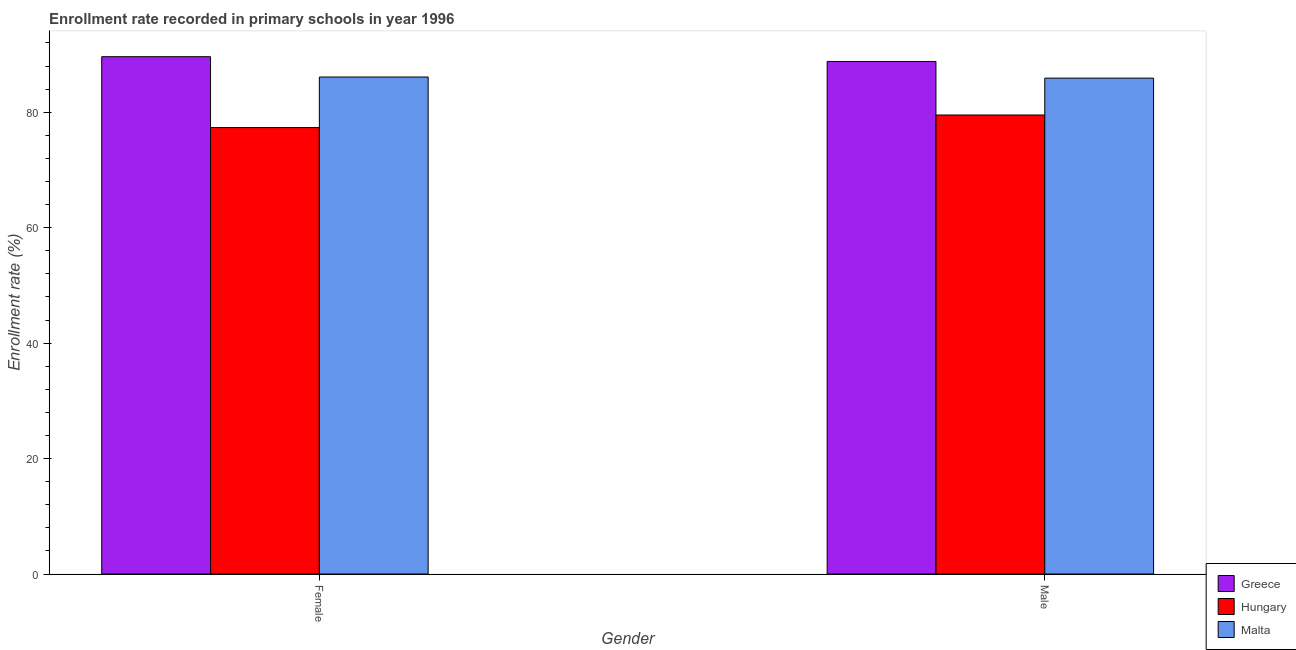Are the number of bars per tick equal to the number of legend labels?
Offer a very short reply. Yes. Are the number of bars on each tick of the X-axis equal?
Offer a very short reply. Yes. How many bars are there on the 1st tick from the right?
Provide a succinct answer. 3. What is the label of the 1st group of bars from the left?
Provide a succinct answer. Female. What is the enrollment rate of female students in Malta?
Ensure brevity in your answer.  86.1. Across all countries, what is the maximum enrollment rate of male students?
Offer a terse response. 88.8. Across all countries, what is the minimum enrollment rate of female students?
Give a very brief answer. 77.34. In which country was the enrollment rate of male students maximum?
Your answer should be very brief. Greece. In which country was the enrollment rate of female students minimum?
Your answer should be compact. Hungary. What is the total enrollment rate of male students in the graph?
Ensure brevity in your answer.  254.22. What is the difference between the enrollment rate of female students in Hungary and that in Malta?
Give a very brief answer. -8.76. What is the difference between the enrollment rate of male students in Greece and the enrollment rate of female students in Hungary?
Keep it short and to the point. 11.45. What is the average enrollment rate of male students per country?
Offer a very short reply. 84.74. What is the difference between the enrollment rate of male students and enrollment rate of female students in Greece?
Your answer should be compact. -0.83. What is the ratio of the enrollment rate of female students in Malta to that in Greece?
Your answer should be very brief. 0.96. Is the enrollment rate of female students in Hungary less than that in Greece?
Offer a terse response. Yes. In how many countries, is the enrollment rate of male students greater than the average enrollment rate of male students taken over all countries?
Offer a terse response. 2. What does the 3rd bar from the left in Female represents?
Your answer should be compact. Malta. What does the 1st bar from the right in Male represents?
Offer a terse response. Malta. Are all the bars in the graph horizontal?
Keep it short and to the point. No. Are the values on the major ticks of Y-axis written in scientific E-notation?
Provide a short and direct response. No. Does the graph contain grids?
Your response must be concise. No. What is the title of the graph?
Offer a terse response. Enrollment rate recorded in primary schools in year 1996. Does "Myanmar" appear as one of the legend labels in the graph?
Provide a succinct answer. No. What is the label or title of the Y-axis?
Provide a short and direct response. Enrollment rate (%). What is the Enrollment rate (%) of Greece in Female?
Provide a succinct answer. 89.62. What is the Enrollment rate (%) in Hungary in Female?
Provide a succinct answer. 77.34. What is the Enrollment rate (%) in Malta in Female?
Provide a succinct answer. 86.1. What is the Enrollment rate (%) of Greece in Male?
Provide a succinct answer. 88.8. What is the Enrollment rate (%) of Hungary in Male?
Your response must be concise. 79.52. What is the Enrollment rate (%) in Malta in Male?
Provide a short and direct response. 85.91. Across all Gender, what is the maximum Enrollment rate (%) in Greece?
Keep it short and to the point. 89.62. Across all Gender, what is the maximum Enrollment rate (%) of Hungary?
Ensure brevity in your answer.  79.52. Across all Gender, what is the maximum Enrollment rate (%) of Malta?
Offer a terse response. 86.1. Across all Gender, what is the minimum Enrollment rate (%) of Greece?
Provide a short and direct response. 88.8. Across all Gender, what is the minimum Enrollment rate (%) in Hungary?
Ensure brevity in your answer.  77.34. Across all Gender, what is the minimum Enrollment rate (%) of Malta?
Provide a succinct answer. 85.91. What is the total Enrollment rate (%) in Greece in the graph?
Ensure brevity in your answer.  178.42. What is the total Enrollment rate (%) of Hungary in the graph?
Your response must be concise. 156.86. What is the total Enrollment rate (%) in Malta in the graph?
Ensure brevity in your answer.  172.01. What is the difference between the Enrollment rate (%) of Greece in Female and that in Male?
Ensure brevity in your answer.  0.83. What is the difference between the Enrollment rate (%) in Hungary in Female and that in Male?
Your answer should be very brief. -2.18. What is the difference between the Enrollment rate (%) of Malta in Female and that in Male?
Provide a short and direct response. 0.2. What is the difference between the Enrollment rate (%) in Greece in Female and the Enrollment rate (%) in Hungary in Male?
Offer a very short reply. 10.1. What is the difference between the Enrollment rate (%) of Greece in Female and the Enrollment rate (%) of Malta in Male?
Ensure brevity in your answer.  3.72. What is the difference between the Enrollment rate (%) in Hungary in Female and the Enrollment rate (%) in Malta in Male?
Ensure brevity in your answer.  -8.56. What is the average Enrollment rate (%) in Greece per Gender?
Your answer should be very brief. 89.21. What is the average Enrollment rate (%) in Hungary per Gender?
Your response must be concise. 78.43. What is the average Enrollment rate (%) in Malta per Gender?
Provide a succinct answer. 86. What is the difference between the Enrollment rate (%) of Greece and Enrollment rate (%) of Hungary in Female?
Give a very brief answer. 12.28. What is the difference between the Enrollment rate (%) of Greece and Enrollment rate (%) of Malta in Female?
Ensure brevity in your answer.  3.52. What is the difference between the Enrollment rate (%) of Hungary and Enrollment rate (%) of Malta in Female?
Ensure brevity in your answer.  -8.76. What is the difference between the Enrollment rate (%) of Greece and Enrollment rate (%) of Hungary in Male?
Provide a short and direct response. 9.28. What is the difference between the Enrollment rate (%) in Greece and Enrollment rate (%) in Malta in Male?
Make the answer very short. 2.89. What is the difference between the Enrollment rate (%) in Hungary and Enrollment rate (%) in Malta in Male?
Make the answer very short. -6.39. What is the ratio of the Enrollment rate (%) of Greece in Female to that in Male?
Offer a terse response. 1.01. What is the ratio of the Enrollment rate (%) in Hungary in Female to that in Male?
Provide a succinct answer. 0.97. What is the ratio of the Enrollment rate (%) in Malta in Female to that in Male?
Make the answer very short. 1. What is the difference between the highest and the second highest Enrollment rate (%) of Greece?
Give a very brief answer. 0.83. What is the difference between the highest and the second highest Enrollment rate (%) of Hungary?
Offer a very short reply. 2.18. What is the difference between the highest and the second highest Enrollment rate (%) of Malta?
Offer a very short reply. 0.2. What is the difference between the highest and the lowest Enrollment rate (%) of Greece?
Offer a terse response. 0.83. What is the difference between the highest and the lowest Enrollment rate (%) in Hungary?
Provide a succinct answer. 2.18. What is the difference between the highest and the lowest Enrollment rate (%) of Malta?
Ensure brevity in your answer.  0.2. 